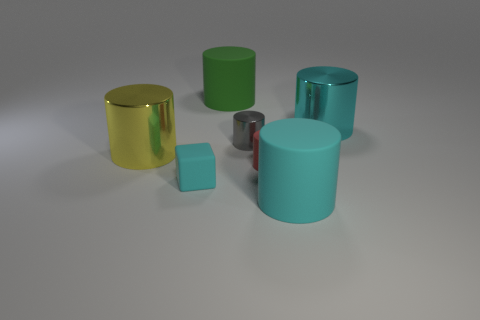Subtract 1 cylinders. How many cylinders are left? 5 Subtract all tiny matte cylinders. How many cylinders are left? 5 Subtract all gray cylinders. How many cylinders are left? 5 Subtract all brown cylinders. Subtract all green balls. How many cylinders are left? 6 Add 2 small matte things. How many objects exist? 9 Subtract all cubes. How many objects are left? 6 Subtract 1 cyan cylinders. How many objects are left? 6 Subtract all tiny purple matte things. Subtract all big green rubber objects. How many objects are left? 6 Add 7 large cyan metal cylinders. How many large cyan metal cylinders are left? 8 Add 6 tiny green objects. How many tiny green objects exist? 6 